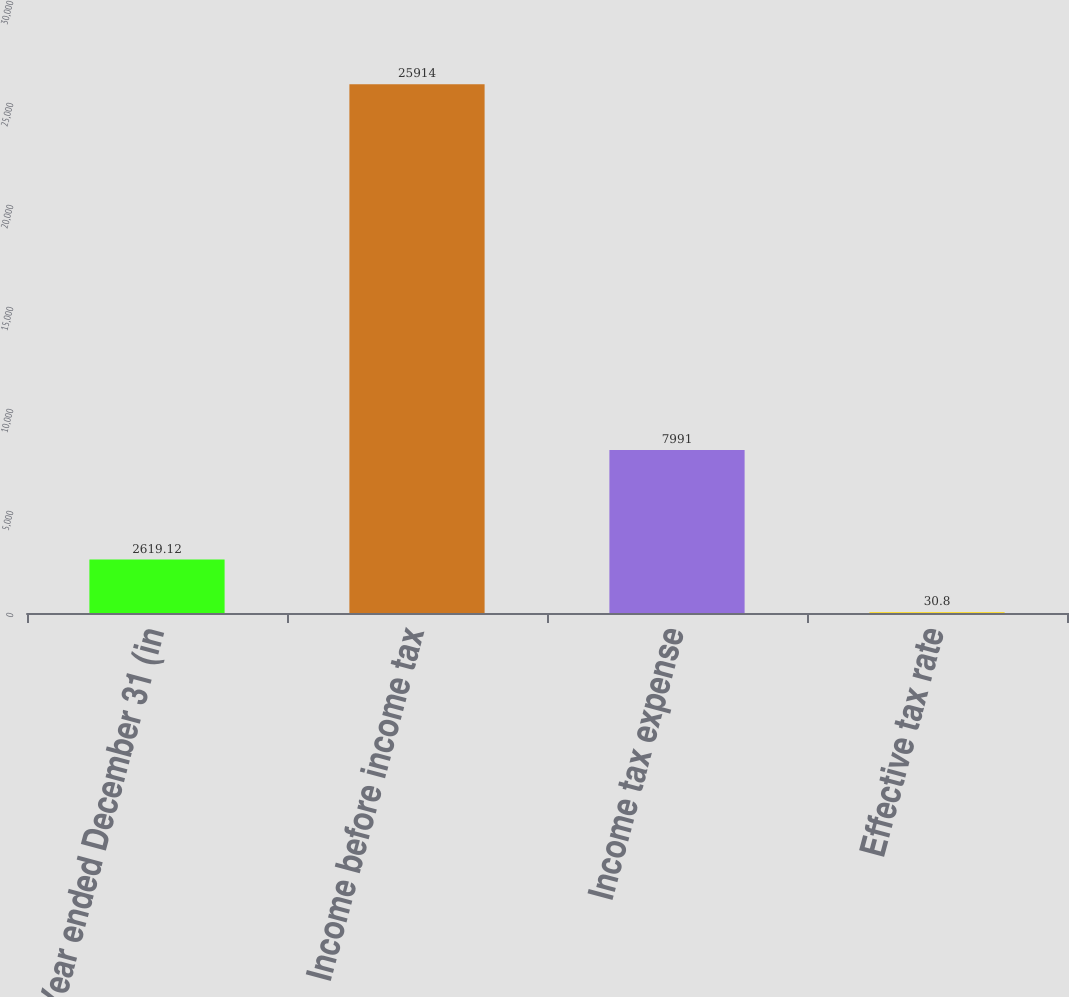Convert chart. <chart><loc_0><loc_0><loc_500><loc_500><bar_chart><fcel>Year ended December 31 (in<fcel>Income before income tax<fcel>Income tax expense<fcel>Effective tax rate<nl><fcel>2619.12<fcel>25914<fcel>7991<fcel>30.8<nl></chart> 